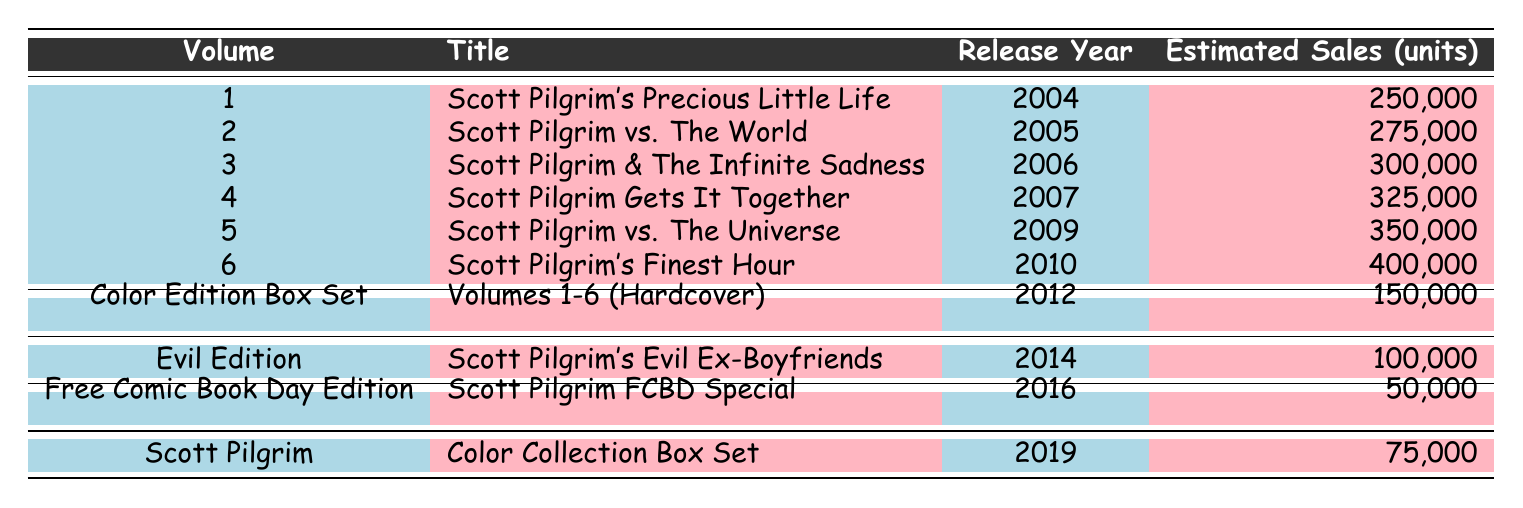What is the title of the first volume? The first volume is listed in the first row under the "Title" column, which indicates "Scott Pilgrim's Precious Little Life."
Answer: Scott Pilgrim's Precious Little Life Which volume has the highest estimated sales? The volume with the highest estimated sales is found by comparing the "Estimated Sales" values, and the highest value is 400,000, which corresponds to "Scott Pilgrim's Finest Hour."
Answer: Scott Pilgrim's Finest Hour In which year was the "Scott Pilgrim vs. The Universe" released? To find the release year, look for "Scott Pilgrim vs. The Universe" in the "Title" column and read across to the "Release Year" column, which shows 2009.
Answer: 2009 What is the total estimated sales for volumes 1 to 6? The total estimated sales for volumes 1 to 6 can be calculated by summing the sales figures: 250,000 + 275,000 + 300,000 + 325,000 + 350,000 + 400,000 = 1,900,000.
Answer: 1,900,000 Is the "Scott Pilgrim FCBD Special" sales figure greater than 100,000? By checking the "Estimated Sales" for "Scott Pilgrim FCBD Special," the figure is 50,000, which is less than 100,000.
Answer: No Which year saw the release of the "Evil Edition"? To find the release year, locate "Scott Pilgrim's Evil Ex-Boyfriends" in the "Title" column. The associated year is listed as 2014.
Answer: 2014 What is the average estimated sales for all volumes listed? The estimated sales figures are 250,000, 275,000, 300,000, 325,000, 350,000, 400,000, 150,000, 100,000, 50,000, and 75,000, which add up to 2,075,000 for 10 volumes, giving an average of 2,075,000 / 10 = 207,500.
Answer: 207,500 How many editions were released after 2010? Looking at the "Release Year" column for any years greater than 2010, the editions released are in 2012, 2014, 2016, and 2019, totaling 4 editions.
Answer: 4 Does any volume have estimated sales of 150,000? Checking the "Estimated Sales" column, "Volumes 1-6 (Hardcover)" listed as the "Color Edition Box Set" has sales of 150,000, confirming that yes, that volume does exist.
Answer: Yes 